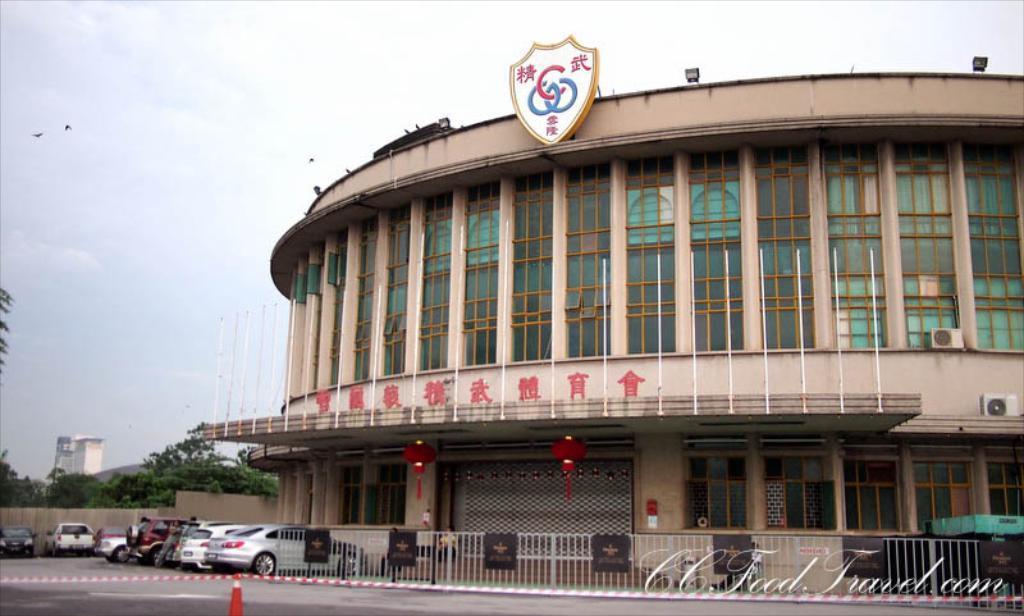In one or two sentences, can you explain what this image depicts? At the bottom we can see a divider on the road and there is a crime scene tape. On the left we can see vehicles on the road,wall,trees,mountain. There is a building,glass doors,windows,poles on the roof,lights and a badge on the wall,AC's,hoardings on the fence and clouds in the sky. 